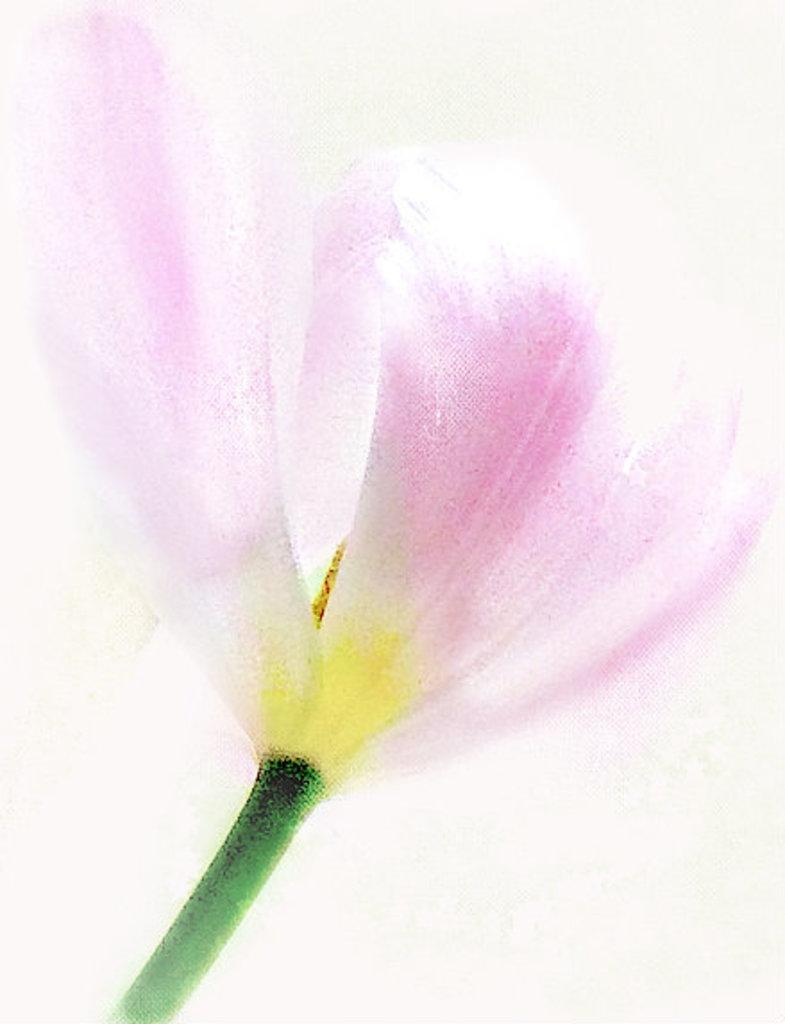What is depicted in the image? There is a painting of a flower in the image. Can you describe the subject of the painting? The painting features a flower as its subject. What type of education does the flower in the painting have? The flower in the painting is not a living being and therefore does not have an education. 